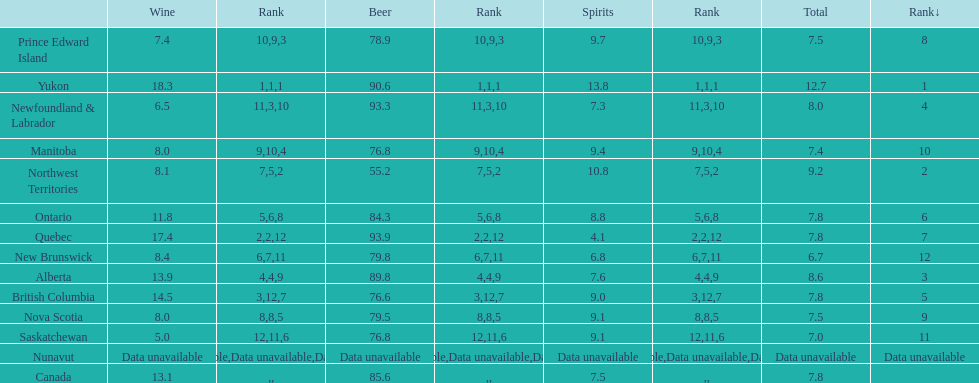Which province is the top consumer of wine? Yukon. 